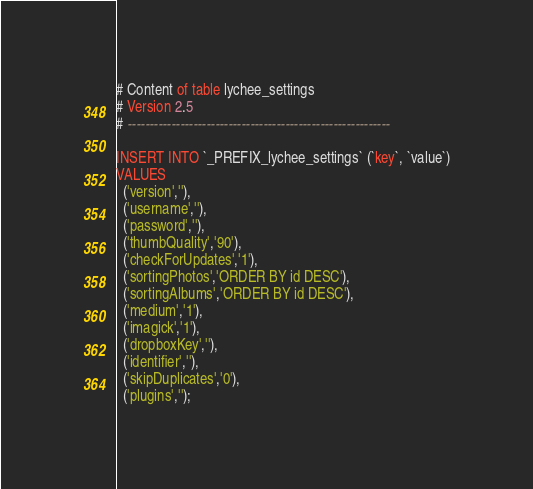<code> <loc_0><loc_0><loc_500><loc_500><_SQL_># Content of table lychee_settings
# Version 2.5
# ------------------------------------------------------------

INSERT INTO `_PREFIX_lychee_settings` (`key`, `value`)
VALUES
  ('version',''),
  ('username',''),
  ('password',''),
  ('thumbQuality','90'),
  ('checkForUpdates','1'),
  ('sortingPhotos','ORDER BY id DESC'),
  ('sortingAlbums','ORDER BY id DESC'),
  ('medium','1'),
  ('imagick','1'),
  ('dropboxKey',''),
  ('identifier',''),
  ('skipDuplicates','0'),
  ('plugins','');

</code> 